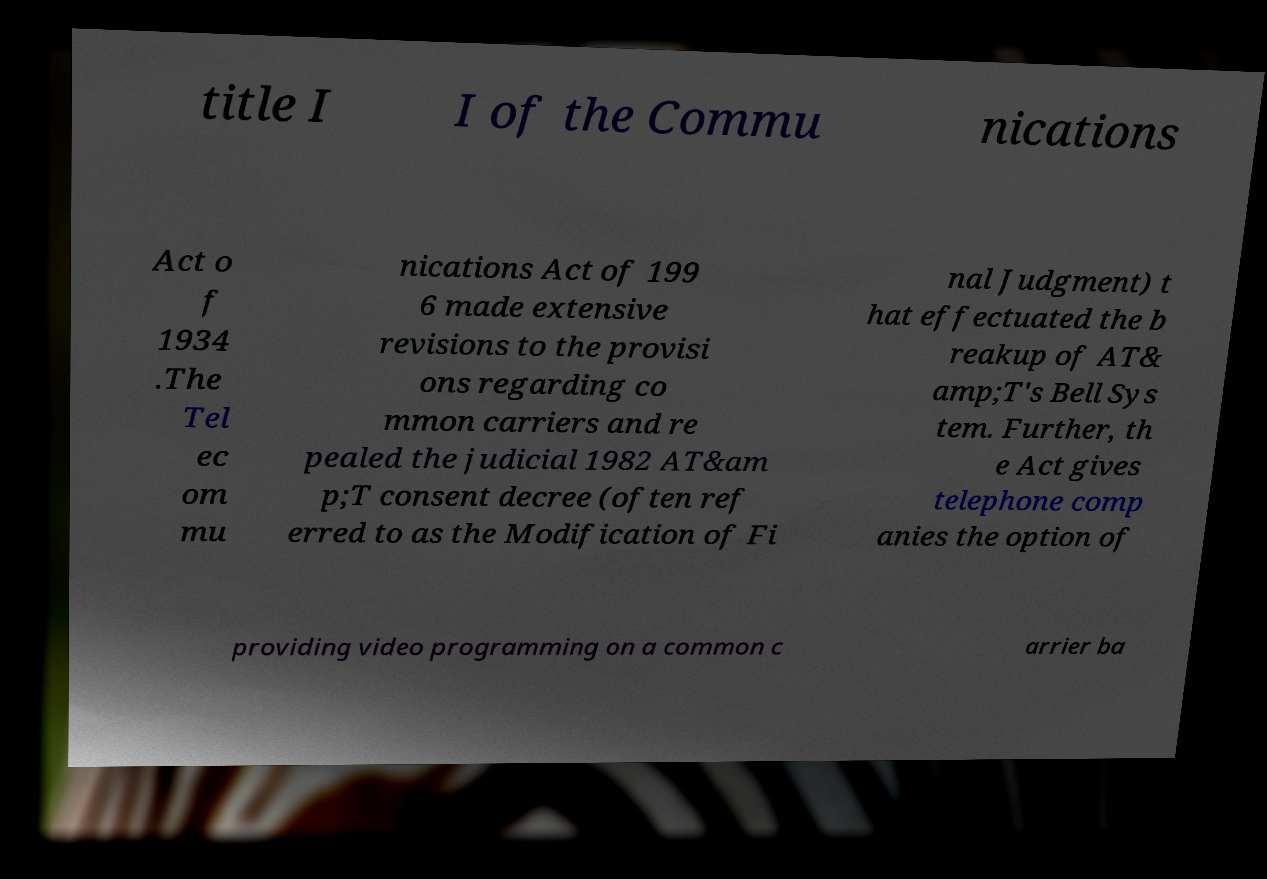Could you extract and type out the text from this image? title I I of the Commu nications Act o f 1934 .The Tel ec om mu nications Act of 199 6 made extensive revisions to the provisi ons regarding co mmon carriers and re pealed the judicial 1982 AT&am p;T consent decree (often ref erred to as the Modification of Fi nal Judgment) t hat effectuated the b reakup of AT& amp;T's Bell Sys tem. Further, th e Act gives telephone comp anies the option of providing video programming on a common c arrier ba 